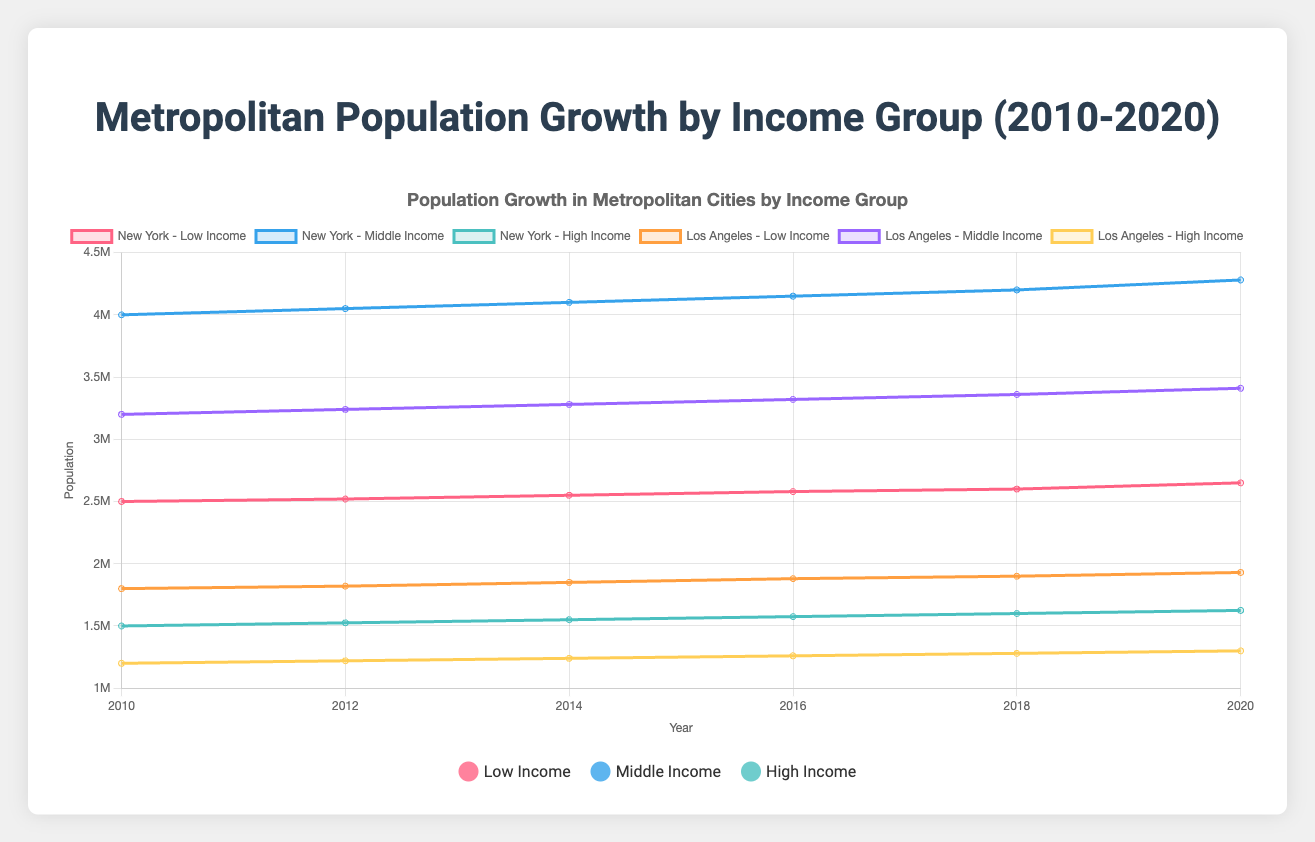What is the overall trend in population growth for the low-income group in New York from 2010 to 2020? The low-income population in New York consistently increases from 2,500,000 in 2010 to 2,650,000 in 2020.
Answer: Increasing Which income group in Los Angeles shows the highest growth rate between 2010 and 2020? Calculate the difference in population for each group: Low-income growth = 1,930,000 - 1,800,000 = 130,000, Middle-income growth = 3,410,000 - 3,200,000 = 210,000, High-income growth = 1,300,000 - 1,200,000 = 100,000. The middle-income group has the highest growth rate.
Answer: Middle-income In 2018, which city has the highest population in the high-income group? Compare the high-income populations in each city in 2018: New York (1,600,000), Los Angeles (1,280,000), Chicago (980,000), Houston (880,000), Miami (780,000). New York has the highest population in the high-income group.
Answer: New York What is the difference in population between the middle-income group of Chicago and Houston in 2020? Middle-income population in 2020: Chicago = 2,550,000, Houston = 2,250,000. The difference is 2,550,000 - 2,250,000 = 300,000.
Answer: 300,000 Which city saw the smallest increase in the low-income group from 2010 to 2020? Calculate the population increase for the low-income group in each city from 2010 to 2020: New York (150,000), Los Angeles (130,000), Chicago (125,000), Houston (130,000), Miami (100,000). Miami has the smallest increase.
Answer: Miami How did the population of the middle-income group in Miami change from 2012 to 2020? The middle-income population in Miami for 2012 is 1,820,000 and for 2020 is 1,900,000. The change is 1,900,000 - 1,820,000 = 80,000 increased.
Answer: Increased by 80,000 Between 2014 and 2018, which city experienced the fastest growth in its high-income group? Calculate the growth for each city from 2014 to 2018: New York (1,600,000 - 1,550,000 = 50,000), Los Angeles (1,280,000 - 1,240,000 = 40,000), Chicago (980,000 - 940,000 = 40,000), Houston (880,000 - 840,000 = 40,000), Miami (780,000 - 740,000 = 40,000). New York experienced the fastest growth.
Answer: New York 